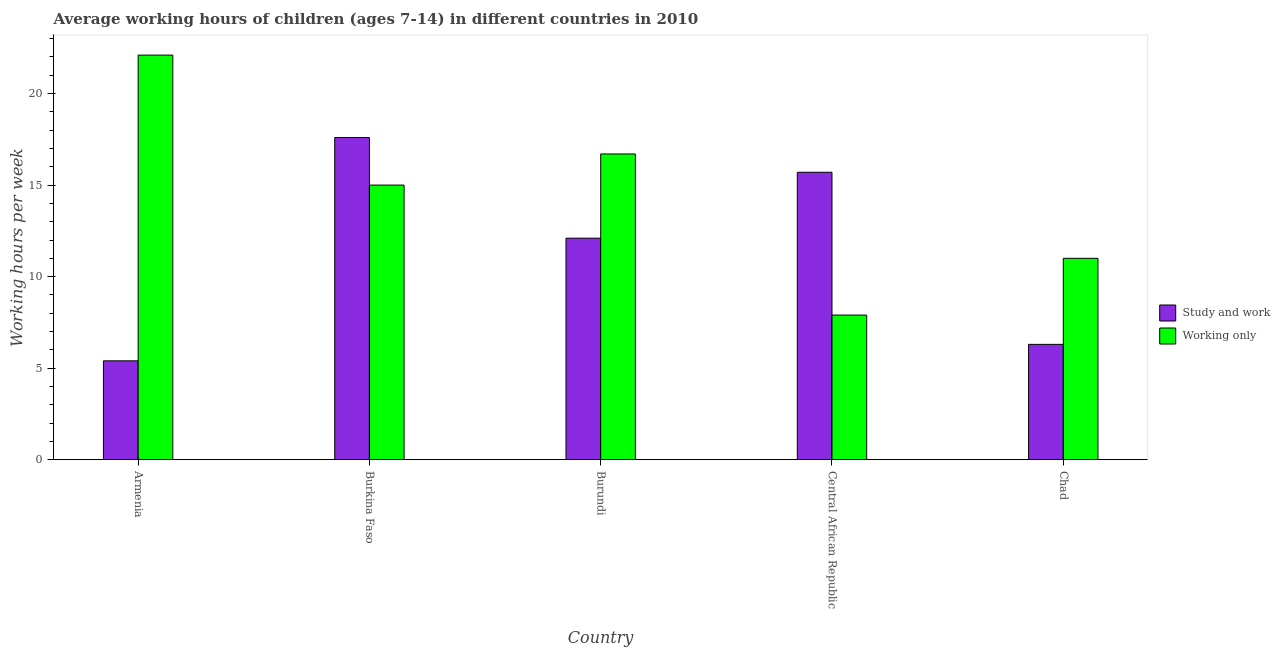How many different coloured bars are there?
Provide a short and direct response. 2. Are the number of bars per tick equal to the number of legend labels?
Provide a short and direct response. Yes. How many bars are there on the 5th tick from the left?
Offer a very short reply. 2. What is the label of the 2nd group of bars from the left?
Your response must be concise. Burkina Faso. Across all countries, what is the maximum average working hour of children involved in study and work?
Offer a terse response. 17.6. In which country was the average working hour of children involved in study and work maximum?
Provide a succinct answer. Burkina Faso. In which country was the average working hour of children involved in study and work minimum?
Offer a terse response. Armenia. What is the total average working hour of children involved in only work in the graph?
Your answer should be very brief. 72.7. What is the difference between the average working hour of children involved in only work in Armenia and that in Central African Republic?
Make the answer very short. 14.2. What is the difference between the average working hour of children involved in only work in Burkina Faso and the average working hour of children involved in study and work in Chad?
Keep it short and to the point. 8.7. What is the average average working hour of children involved in study and work per country?
Offer a very short reply. 11.42. What is the difference between the average working hour of children involved in study and work and average working hour of children involved in only work in Central African Republic?
Provide a short and direct response. 7.8. What is the ratio of the average working hour of children involved in only work in Armenia to that in Burundi?
Your response must be concise. 1.32. Is the average working hour of children involved in only work in Burkina Faso less than that in Burundi?
Your answer should be very brief. Yes. What is the difference between the highest and the second highest average working hour of children involved in study and work?
Make the answer very short. 1.9. What is the difference between the highest and the lowest average working hour of children involved in only work?
Provide a short and direct response. 14.2. What does the 1st bar from the left in Central African Republic represents?
Provide a short and direct response. Study and work. What does the 1st bar from the right in Burkina Faso represents?
Offer a very short reply. Working only. Are all the bars in the graph horizontal?
Give a very brief answer. No. How many countries are there in the graph?
Provide a succinct answer. 5. How many legend labels are there?
Provide a short and direct response. 2. How are the legend labels stacked?
Offer a terse response. Vertical. What is the title of the graph?
Ensure brevity in your answer.  Average working hours of children (ages 7-14) in different countries in 2010. What is the label or title of the X-axis?
Make the answer very short. Country. What is the label or title of the Y-axis?
Provide a succinct answer. Working hours per week. What is the Working hours per week of Working only in Armenia?
Keep it short and to the point. 22.1. What is the Working hours per week of Study and work in Burkina Faso?
Keep it short and to the point. 17.6. What is the Working hours per week of Study and work in Burundi?
Make the answer very short. 12.1. What is the Working hours per week of Working only in Burundi?
Provide a short and direct response. 16.7. What is the Working hours per week of Study and work in Central African Republic?
Your answer should be compact. 15.7. What is the Working hours per week in Study and work in Chad?
Ensure brevity in your answer.  6.3. What is the Working hours per week in Working only in Chad?
Keep it short and to the point. 11. Across all countries, what is the maximum Working hours per week in Working only?
Give a very brief answer. 22.1. What is the total Working hours per week of Study and work in the graph?
Ensure brevity in your answer.  57.1. What is the total Working hours per week of Working only in the graph?
Give a very brief answer. 72.7. What is the difference between the Working hours per week in Study and work in Armenia and that in Burkina Faso?
Your response must be concise. -12.2. What is the difference between the Working hours per week of Study and work in Armenia and that in Burundi?
Provide a succinct answer. -6.7. What is the difference between the Working hours per week of Study and work in Burkina Faso and that in Burundi?
Your answer should be very brief. 5.5. What is the difference between the Working hours per week of Study and work in Burkina Faso and that in Central African Republic?
Ensure brevity in your answer.  1.9. What is the difference between the Working hours per week of Study and work in Burkina Faso and that in Chad?
Make the answer very short. 11.3. What is the difference between the Working hours per week of Working only in Burkina Faso and that in Chad?
Ensure brevity in your answer.  4. What is the difference between the Working hours per week in Working only in Burundi and that in Central African Republic?
Offer a very short reply. 8.8. What is the difference between the Working hours per week in Study and work in Armenia and the Working hours per week in Working only in Burkina Faso?
Provide a short and direct response. -9.6. What is the difference between the Working hours per week of Study and work in Armenia and the Working hours per week of Working only in Central African Republic?
Provide a short and direct response. -2.5. What is the difference between the Working hours per week in Study and work in Armenia and the Working hours per week in Working only in Chad?
Provide a short and direct response. -5.6. What is the difference between the Working hours per week of Study and work in Burkina Faso and the Working hours per week of Working only in Central African Republic?
Offer a very short reply. 9.7. What is the difference between the Working hours per week in Study and work in Burkina Faso and the Working hours per week in Working only in Chad?
Give a very brief answer. 6.6. What is the difference between the Working hours per week in Study and work in Central African Republic and the Working hours per week in Working only in Chad?
Offer a very short reply. 4.7. What is the average Working hours per week in Study and work per country?
Provide a short and direct response. 11.42. What is the average Working hours per week in Working only per country?
Your response must be concise. 14.54. What is the difference between the Working hours per week in Study and work and Working hours per week in Working only in Armenia?
Offer a very short reply. -16.7. What is the difference between the Working hours per week in Study and work and Working hours per week in Working only in Central African Republic?
Your response must be concise. 7.8. What is the ratio of the Working hours per week of Study and work in Armenia to that in Burkina Faso?
Your answer should be very brief. 0.31. What is the ratio of the Working hours per week in Working only in Armenia to that in Burkina Faso?
Provide a succinct answer. 1.47. What is the ratio of the Working hours per week in Study and work in Armenia to that in Burundi?
Your answer should be very brief. 0.45. What is the ratio of the Working hours per week in Working only in Armenia to that in Burundi?
Keep it short and to the point. 1.32. What is the ratio of the Working hours per week in Study and work in Armenia to that in Central African Republic?
Give a very brief answer. 0.34. What is the ratio of the Working hours per week of Working only in Armenia to that in Central African Republic?
Offer a terse response. 2.8. What is the ratio of the Working hours per week of Working only in Armenia to that in Chad?
Provide a short and direct response. 2.01. What is the ratio of the Working hours per week of Study and work in Burkina Faso to that in Burundi?
Offer a terse response. 1.45. What is the ratio of the Working hours per week in Working only in Burkina Faso to that in Burundi?
Ensure brevity in your answer.  0.9. What is the ratio of the Working hours per week in Study and work in Burkina Faso to that in Central African Republic?
Your answer should be compact. 1.12. What is the ratio of the Working hours per week in Working only in Burkina Faso to that in Central African Republic?
Offer a terse response. 1.9. What is the ratio of the Working hours per week of Study and work in Burkina Faso to that in Chad?
Provide a succinct answer. 2.79. What is the ratio of the Working hours per week in Working only in Burkina Faso to that in Chad?
Provide a succinct answer. 1.36. What is the ratio of the Working hours per week of Study and work in Burundi to that in Central African Republic?
Ensure brevity in your answer.  0.77. What is the ratio of the Working hours per week in Working only in Burundi to that in Central African Republic?
Make the answer very short. 2.11. What is the ratio of the Working hours per week of Study and work in Burundi to that in Chad?
Provide a succinct answer. 1.92. What is the ratio of the Working hours per week in Working only in Burundi to that in Chad?
Your answer should be very brief. 1.52. What is the ratio of the Working hours per week of Study and work in Central African Republic to that in Chad?
Your response must be concise. 2.49. What is the ratio of the Working hours per week in Working only in Central African Republic to that in Chad?
Your response must be concise. 0.72. What is the difference between the highest and the second highest Working hours per week in Study and work?
Your response must be concise. 1.9. What is the difference between the highest and the second highest Working hours per week of Working only?
Offer a very short reply. 5.4. What is the difference between the highest and the lowest Working hours per week in Study and work?
Offer a very short reply. 12.2. What is the difference between the highest and the lowest Working hours per week in Working only?
Keep it short and to the point. 14.2. 